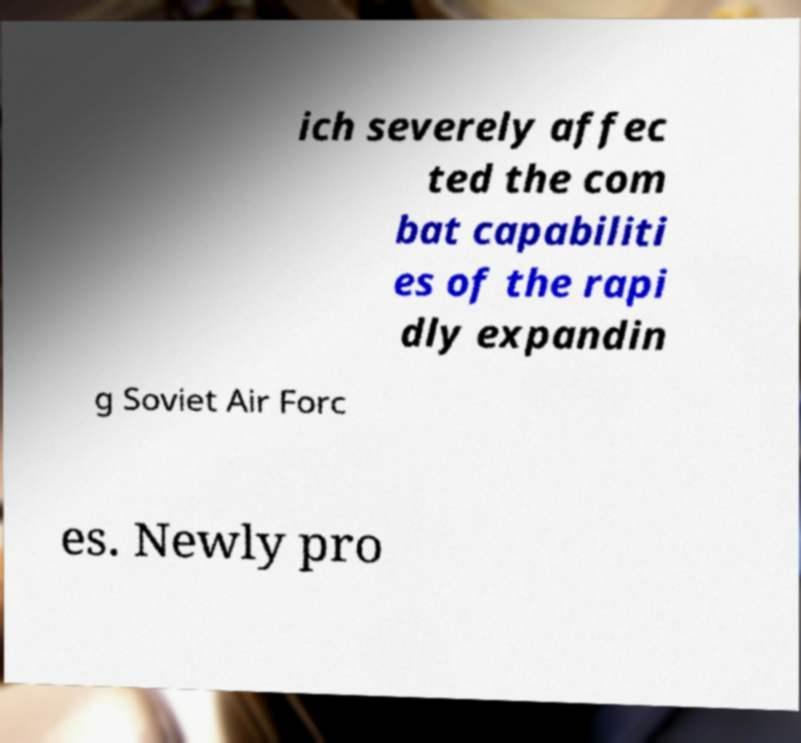For documentation purposes, I need the text within this image transcribed. Could you provide that? ich severely affec ted the com bat capabiliti es of the rapi dly expandin g Soviet Air Forc es. Newly pro 